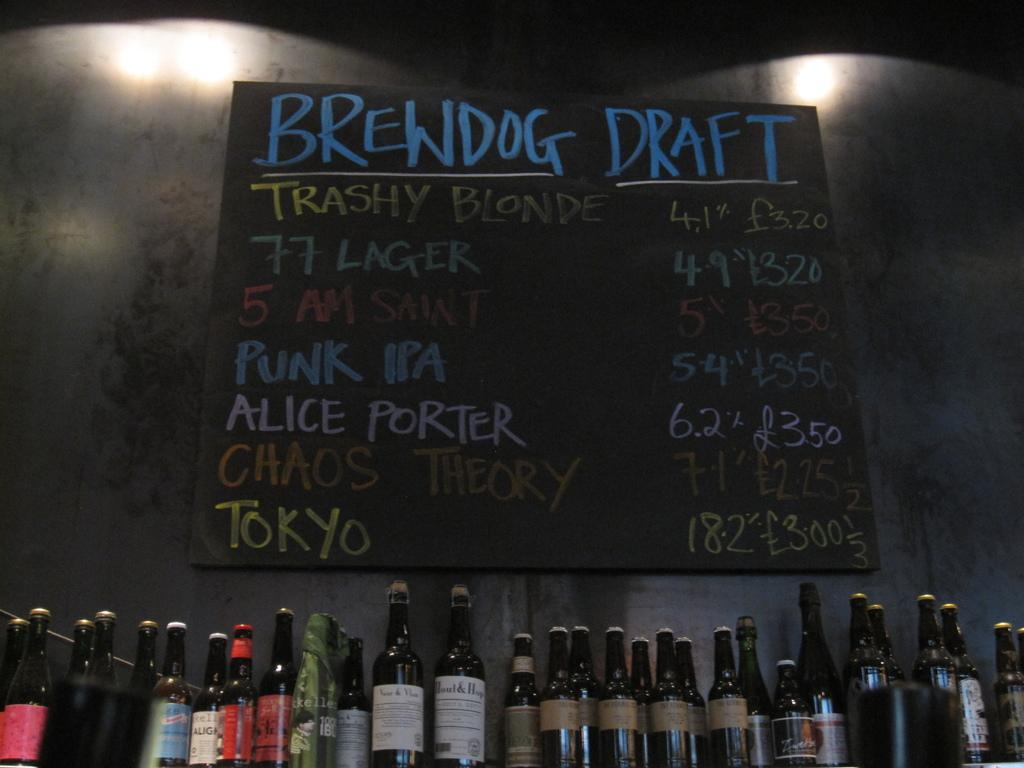<image>
Summarize the visual content of the image. A black menu board showing the offerings of many types beer. 